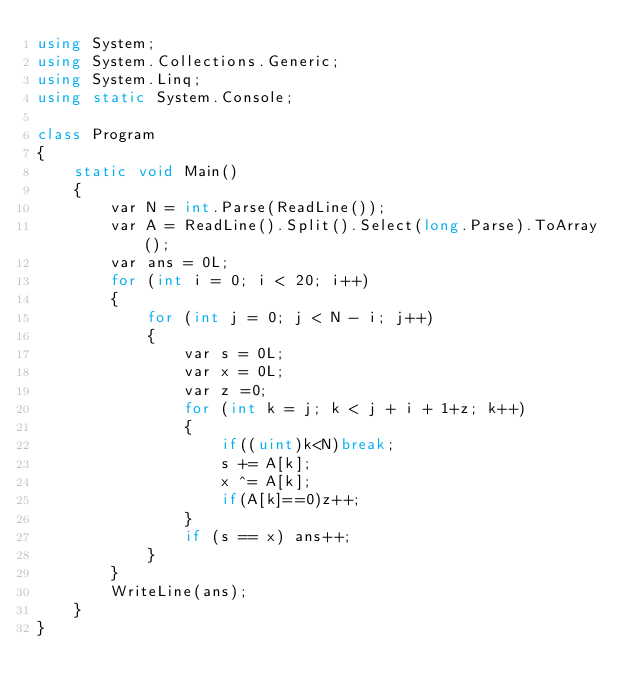Convert code to text. <code><loc_0><loc_0><loc_500><loc_500><_C#_>using System;
using System.Collections.Generic;
using System.Linq;
using static System.Console;

class Program
{
    static void Main()
    {
        var N = int.Parse(ReadLine());
        var A = ReadLine().Split().Select(long.Parse).ToArray();
        var ans = 0L;
        for (int i = 0; i < 20; i++)
        {
            for (int j = 0; j < N - i; j++)
            {
                var s = 0L;
                var x = 0L;
                var z =0;
                for (int k = j; k < j + i + 1+z; k++)
                {
                    if((uint)k<N)break;
                    s += A[k];
                    x ^= A[k];
                    if(A[k]==0)z++;
                }
                if (s == x) ans++;
            }
        }
        WriteLine(ans);
    }
}</code> 